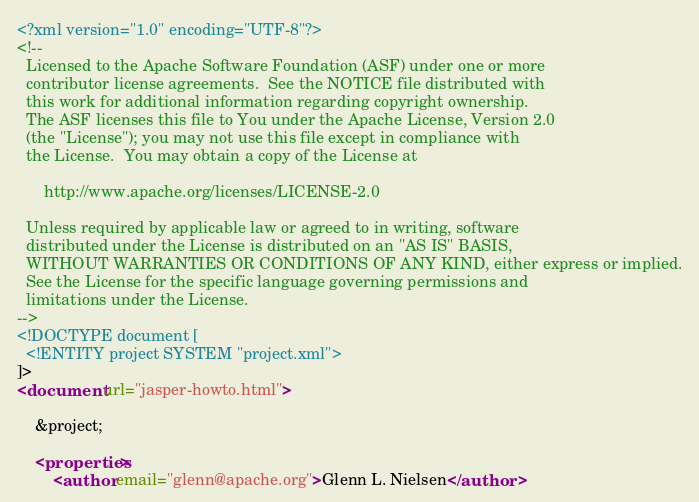Convert code to text. <code><loc_0><loc_0><loc_500><loc_500><_XML_><?xml version="1.0" encoding="UTF-8"?>
<!--
  Licensed to the Apache Software Foundation (ASF) under one or more
  contributor license agreements.  See the NOTICE file distributed with
  this work for additional information regarding copyright ownership.
  The ASF licenses this file to You under the Apache License, Version 2.0
  (the "License"); you may not use this file except in compliance with
  the License.  You may obtain a copy of the License at

      http://www.apache.org/licenses/LICENSE-2.0

  Unless required by applicable law or agreed to in writing, software
  distributed under the License is distributed on an "AS IS" BASIS,
  WITHOUT WARRANTIES OR CONDITIONS OF ANY KIND, either express or implied.
  See the License for the specific language governing permissions and
  limitations under the License.
-->
<!DOCTYPE document [
  <!ENTITY project SYSTEM "project.xml">
]>
<document url="jasper-howto.html">

    &project;

    <properties>
        <author email="glenn@apache.org">Glenn L. Nielsen</author></code> 